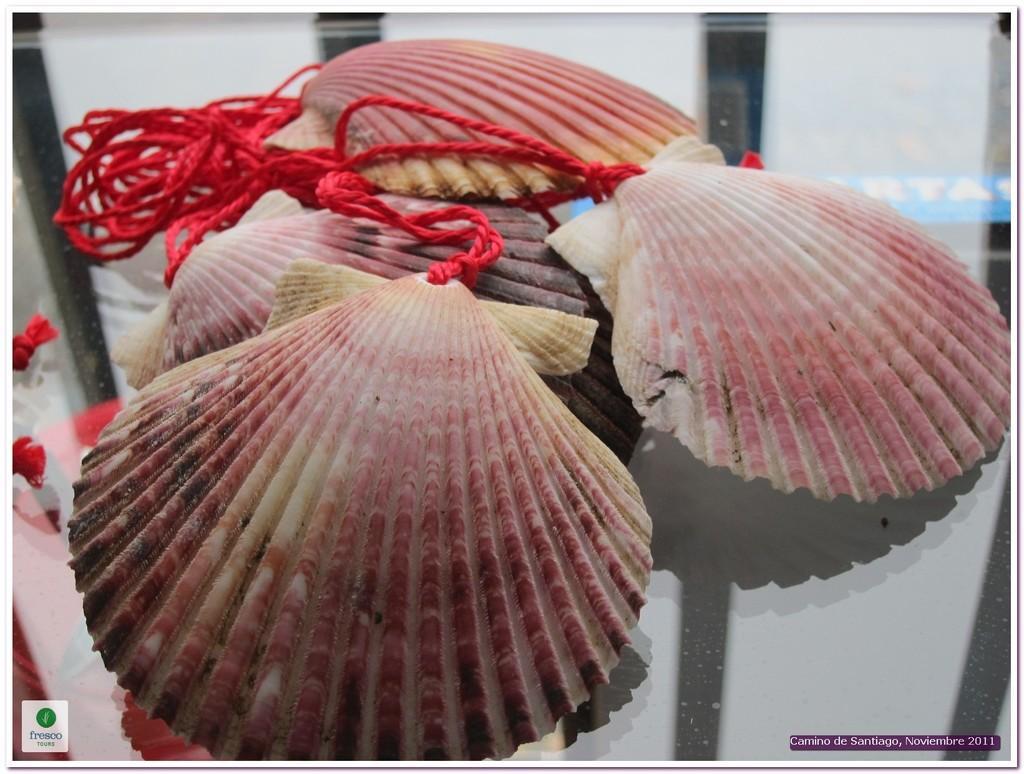Please provide a concise description of this image. In this image we can see there are shells and ropes are connected to it. At the bottom of the image we can see there some text. 